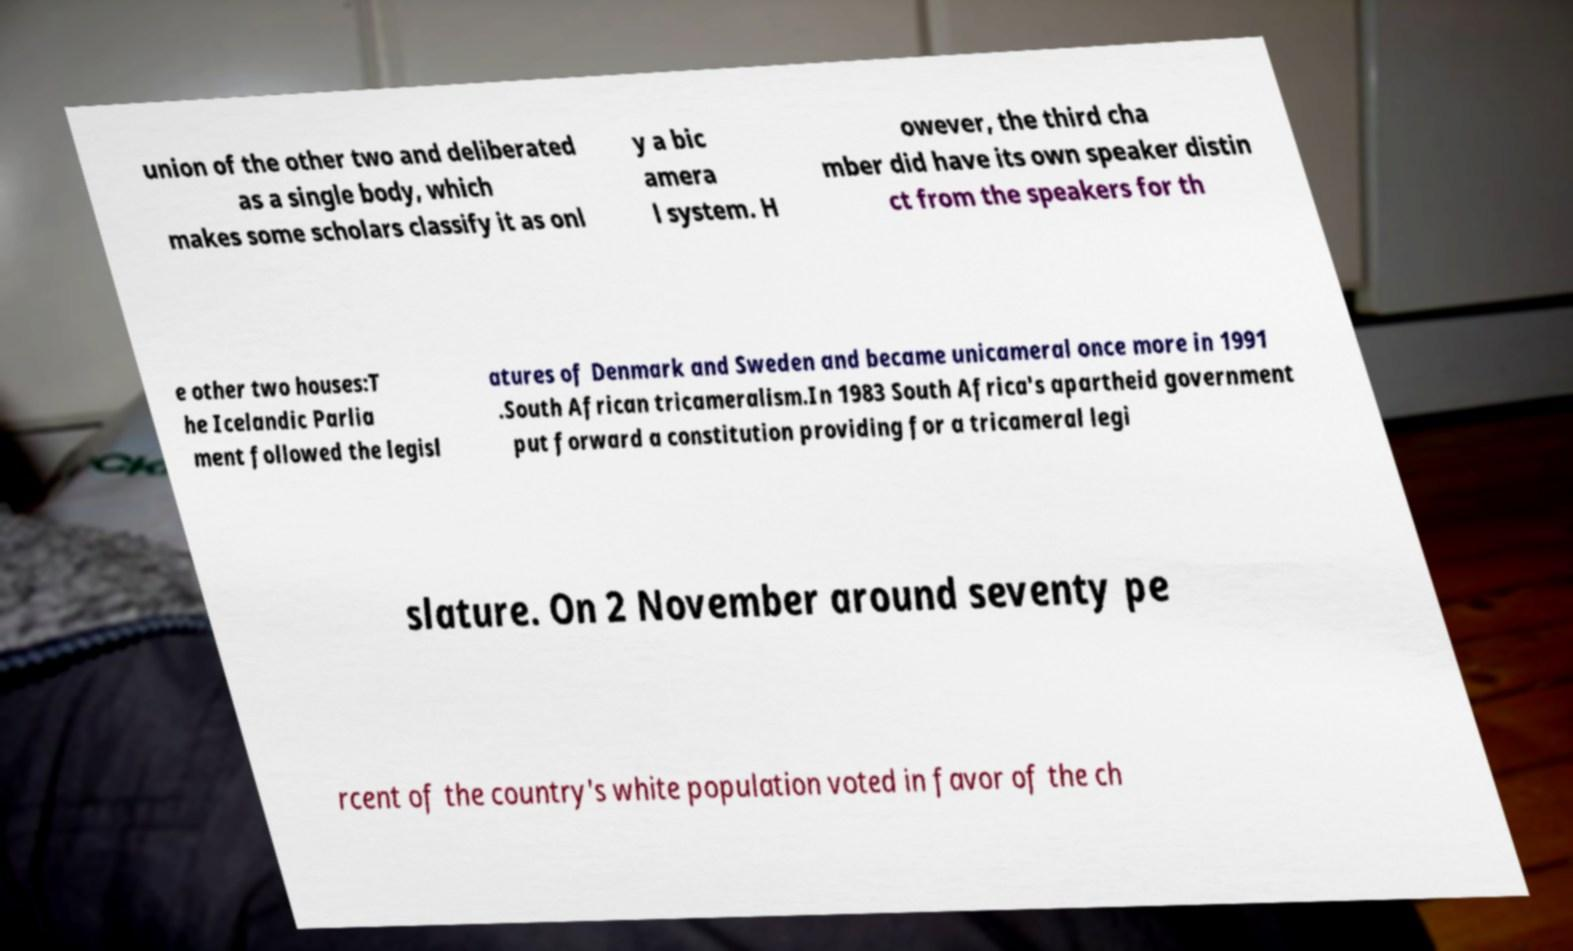Please read and relay the text visible in this image. What does it say? union of the other two and deliberated as a single body, which makes some scholars classify it as onl y a bic amera l system. H owever, the third cha mber did have its own speaker distin ct from the speakers for th e other two houses:T he Icelandic Parlia ment followed the legisl atures of Denmark and Sweden and became unicameral once more in 1991 .South African tricameralism.In 1983 South Africa's apartheid government put forward a constitution providing for a tricameral legi slature. On 2 November around seventy pe rcent of the country's white population voted in favor of the ch 